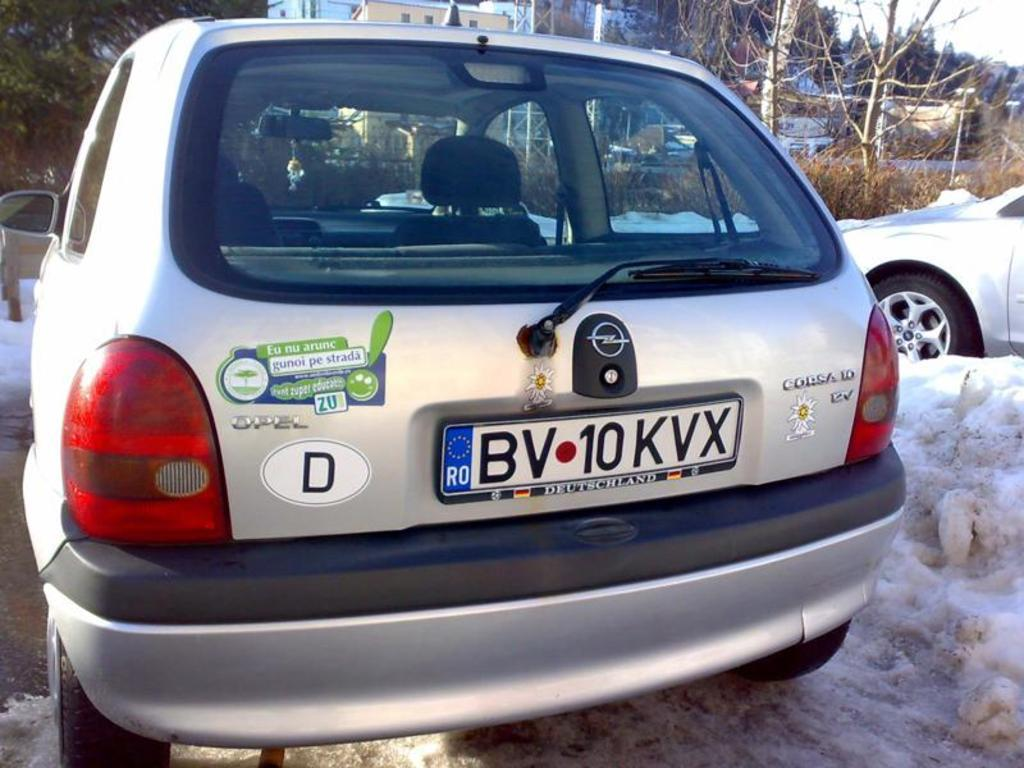<image>
Summarize the visual content of the image. a opel corsica car with a dutch license 